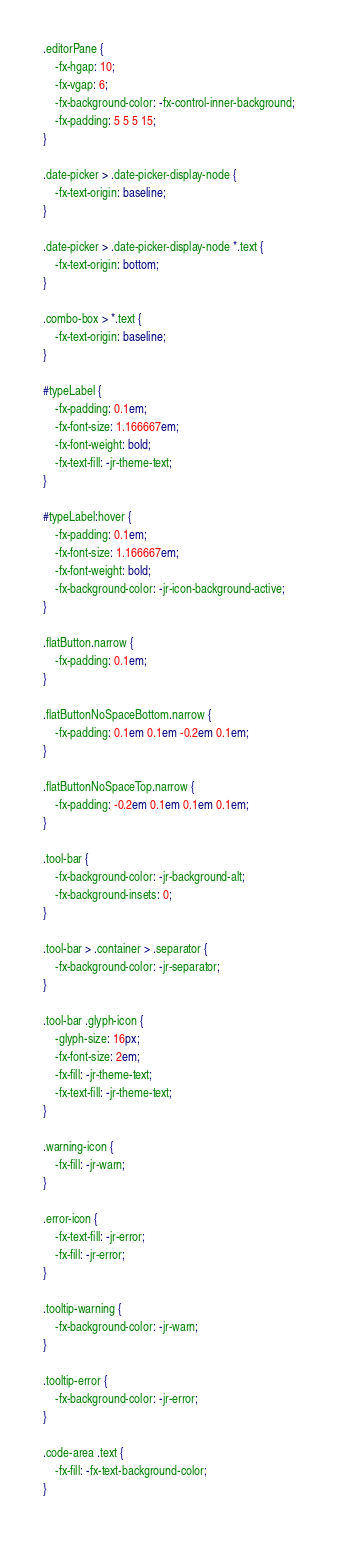Convert code to text. <code><loc_0><loc_0><loc_500><loc_500><_CSS_>.editorPane {
    -fx-hgap: 10;
    -fx-vgap: 6;
    -fx-background-color: -fx-control-inner-background;
    -fx-padding: 5 5 5 15;
}

.date-picker > .date-picker-display-node {
    -fx-text-origin: baseline;
}

.date-picker > .date-picker-display-node *.text {
    -fx-text-origin: bottom;
}

.combo-box > *.text {
    -fx-text-origin: baseline;
}

#typeLabel {
    -fx-padding: 0.1em;
    -fx-font-size: 1.166667em;
    -fx-font-weight: bold;
    -fx-text-fill: -jr-theme-text;
}

#typeLabel:hover {
    -fx-padding: 0.1em;
    -fx-font-size: 1.166667em;
    -fx-font-weight: bold;
    -fx-background-color: -jr-icon-background-active;
}

.flatButton.narrow {
    -fx-padding: 0.1em;
}

.flatButtonNoSpaceBottom.narrow {
    -fx-padding: 0.1em 0.1em -0.2em 0.1em;
}

.flatButtonNoSpaceTop.narrow {
    -fx-padding: -0.2em 0.1em 0.1em 0.1em;
}

.tool-bar {
    -fx-background-color: -jr-background-alt;
    -fx-background-insets: 0;
}

.tool-bar > .container > .separator {
    -fx-background-color: -jr-separator;
}

.tool-bar .glyph-icon {
    -glyph-size: 16px;
    -fx-font-size: 2em;
    -fx-fill: -jr-theme-text;
    -fx-text-fill: -jr-theme-text;
}

.warning-icon {
    -fx-fill: -jr-warn;
}

.error-icon {
    -fx-text-fill: -jr-error;
    -fx-fill: -jr-error;
}

.tooltip-warning {
    -fx-background-color: -jr-warn;
}

.tooltip-error {
    -fx-background-color: -jr-error;
}

.code-area .text {
    -fx-fill: -fx-text-background-color;
}
</code> 